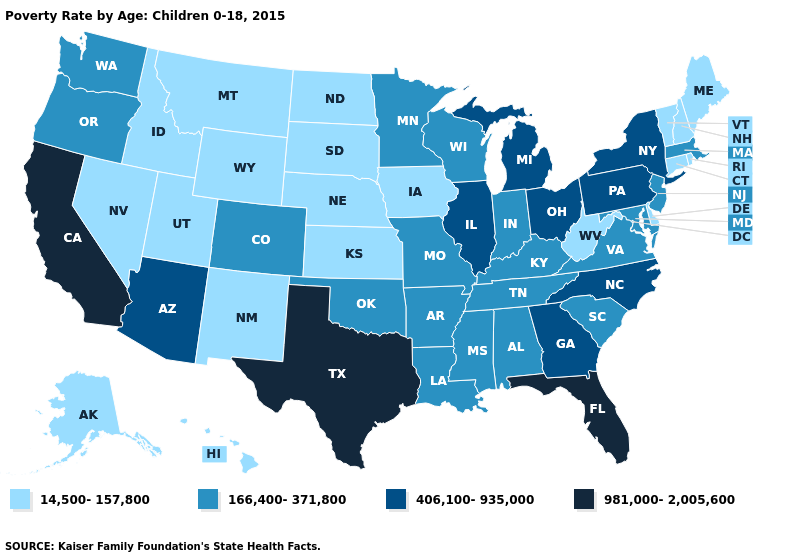What is the highest value in the Northeast ?
Answer briefly. 406,100-935,000. What is the lowest value in the South?
Concise answer only. 14,500-157,800. Name the states that have a value in the range 166,400-371,800?
Answer briefly. Alabama, Arkansas, Colorado, Indiana, Kentucky, Louisiana, Maryland, Massachusetts, Minnesota, Mississippi, Missouri, New Jersey, Oklahoma, Oregon, South Carolina, Tennessee, Virginia, Washington, Wisconsin. Does Massachusetts have a higher value than Hawaii?
Short answer required. Yes. What is the lowest value in the USA?
Quick response, please. 14,500-157,800. Which states hav the highest value in the West?
Short answer required. California. Name the states that have a value in the range 981,000-2,005,600?
Quick response, please. California, Florida, Texas. What is the value of Washington?
Write a very short answer. 166,400-371,800. Name the states that have a value in the range 406,100-935,000?
Keep it brief. Arizona, Georgia, Illinois, Michigan, New York, North Carolina, Ohio, Pennsylvania. Does Tennessee have a higher value than Alabama?
Be succinct. No. Among the states that border Arkansas , does Tennessee have the lowest value?
Quick response, please. Yes. What is the value of Ohio?
Concise answer only. 406,100-935,000. Does New York have the same value as Virginia?
Keep it brief. No. What is the lowest value in states that border South Dakota?
Concise answer only. 14,500-157,800. Name the states that have a value in the range 981,000-2,005,600?
Answer briefly. California, Florida, Texas. 